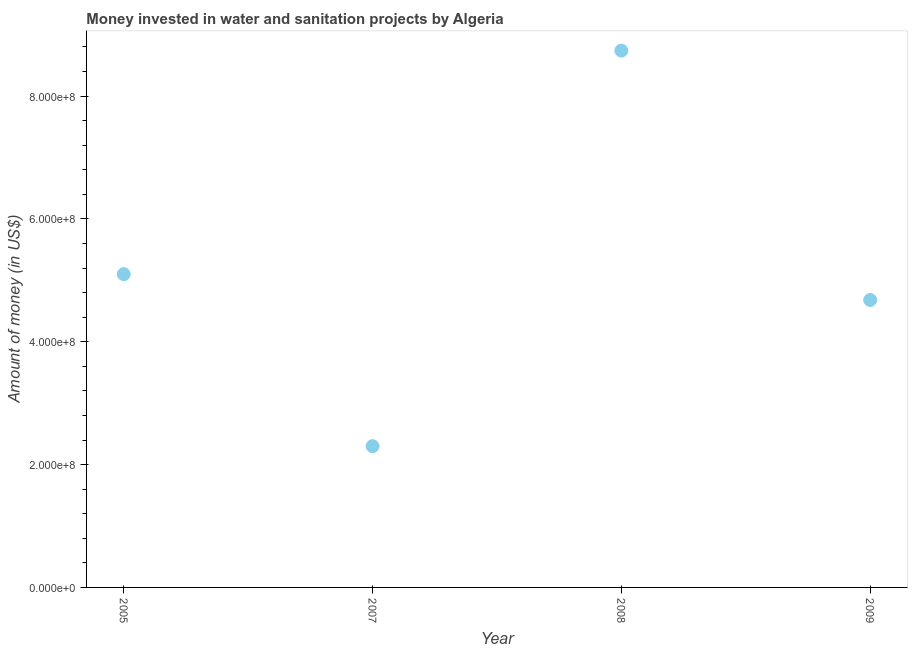What is the investment in 2007?
Your answer should be compact. 2.30e+08. Across all years, what is the maximum investment?
Keep it short and to the point. 8.74e+08. Across all years, what is the minimum investment?
Your response must be concise. 2.30e+08. What is the sum of the investment?
Your answer should be compact. 2.08e+09. What is the difference between the investment in 2007 and 2009?
Your answer should be very brief. -2.38e+08. What is the average investment per year?
Provide a short and direct response. 5.20e+08. What is the median investment?
Keep it short and to the point. 4.89e+08. Do a majority of the years between 2007 and 2008 (inclusive) have investment greater than 120000000 US$?
Your answer should be compact. Yes. What is the ratio of the investment in 2007 to that in 2009?
Your response must be concise. 0.49. Is the investment in 2008 less than that in 2009?
Make the answer very short. No. What is the difference between the highest and the second highest investment?
Provide a short and direct response. 3.64e+08. Is the sum of the investment in 2008 and 2009 greater than the maximum investment across all years?
Make the answer very short. Yes. What is the difference between the highest and the lowest investment?
Keep it short and to the point. 6.44e+08. In how many years, is the investment greater than the average investment taken over all years?
Offer a terse response. 1. Does the investment monotonically increase over the years?
Your answer should be very brief. No. How many dotlines are there?
Keep it short and to the point. 1. What is the difference between two consecutive major ticks on the Y-axis?
Ensure brevity in your answer.  2.00e+08. Are the values on the major ticks of Y-axis written in scientific E-notation?
Your response must be concise. Yes. Does the graph contain any zero values?
Provide a succinct answer. No. Does the graph contain grids?
Keep it short and to the point. No. What is the title of the graph?
Your answer should be compact. Money invested in water and sanitation projects by Algeria. What is the label or title of the Y-axis?
Your answer should be very brief. Amount of money (in US$). What is the Amount of money (in US$) in 2005?
Your response must be concise. 5.10e+08. What is the Amount of money (in US$) in 2007?
Offer a terse response. 2.30e+08. What is the Amount of money (in US$) in 2008?
Provide a succinct answer. 8.74e+08. What is the Amount of money (in US$) in 2009?
Your response must be concise. 4.68e+08. What is the difference between the Amount of money (in US$) in 2005 and 2007?
Keep it short and to the point. 2.80e+08. What is the difference between the Amount of money (in US$) in 2005 and 2008?
Keep it short and to the point. -3.64e+08. What is the difference between the Amount of money (in US$) in 2005 and 2009?
Provide a succinct answer. 4.20e+07. What is the difference between the Amount of money (in US$) in 2007 and 2008?
Provide a short and direct response. -6.44e+08. What is the difference between the Amount of money (in US$) in 2007 and 2009?
Ensure brevity in your answer.  -2.38e+08. What is the difference between the Amount of money (in US$) in 2008 and 2009?
Your answer should be compact. 4.06e+08. What is the ratio of the Amount of money (in US$) in 2005 to that in 2007?
Give a very brief answer. 2.22. What is the ratio of the Amount of money (in US$) in 2005 to that in 2008?
Offer a terse response. 0.58. What is the ratio of the Amount of money (in US$) in 2005 to that in 2009?
Your response must be concise. 1.09. What is the ratio of the Amount of money (in US$) in 2007 to that in 2008?
Keep it short and to the point. 0.26. What is the ratio of the Amount of money (in US$) in 2007 to that in 2009?
Provide a succinct answer. 0.49. What is the ratio of the Amount of money (in US$) in 2008 to that in 2009?
Your response must be concise. 1.87. 